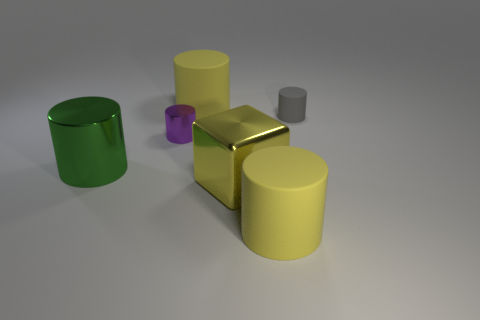How many things are either big yellow cylinders that are behind the tiny purple metal thing or rubber cylinders that are on the right side of the small purple metallic object?
Offer a terse response. 3. Is the size of the gray thing the same as the shiny object that is behind the green shiny cylinder?
Ensure brevity in your answer.  Yes. Do the yellow block that is left of the tiny rubber object and the tiny cylinder behind the purple metal cylinder have the same material?
Your answer should be very brief. No. Is the number of purple metal things that are in front of the large yellow shiny block the same as the number of gray objects to the right of the small rubber thing?
Your response must be concise. Yes. What number of small shiny cylinders have the same color as the large metal cylinder?
Offer a terse response. 0. What number of metallic objects are large cubes or yellow things?
Keep it short and to the point. 1. There is a yellow matte thing that is behind the small metal cylinder; does it have the same shape as the big shiny thing that is right of the green shiny object?
Offer a very short reply. No. There is a yellow metallic thing; what number of big green cylinders are on the right side of it?
Ensure brevity in your answer.  0. Are there any blocks that have the same material as the green cylinder?
Ensure brevity in your answer.  Yes. There is a green cylinder that is the same size as the yellow metal thing; what material is it?
Make the answer very short. Metal. 